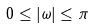Convert formula to latex. <formula><loc_0><loc_0><loc_500><loc_500>0 \leq | \omega | \leq \pi</formula> 